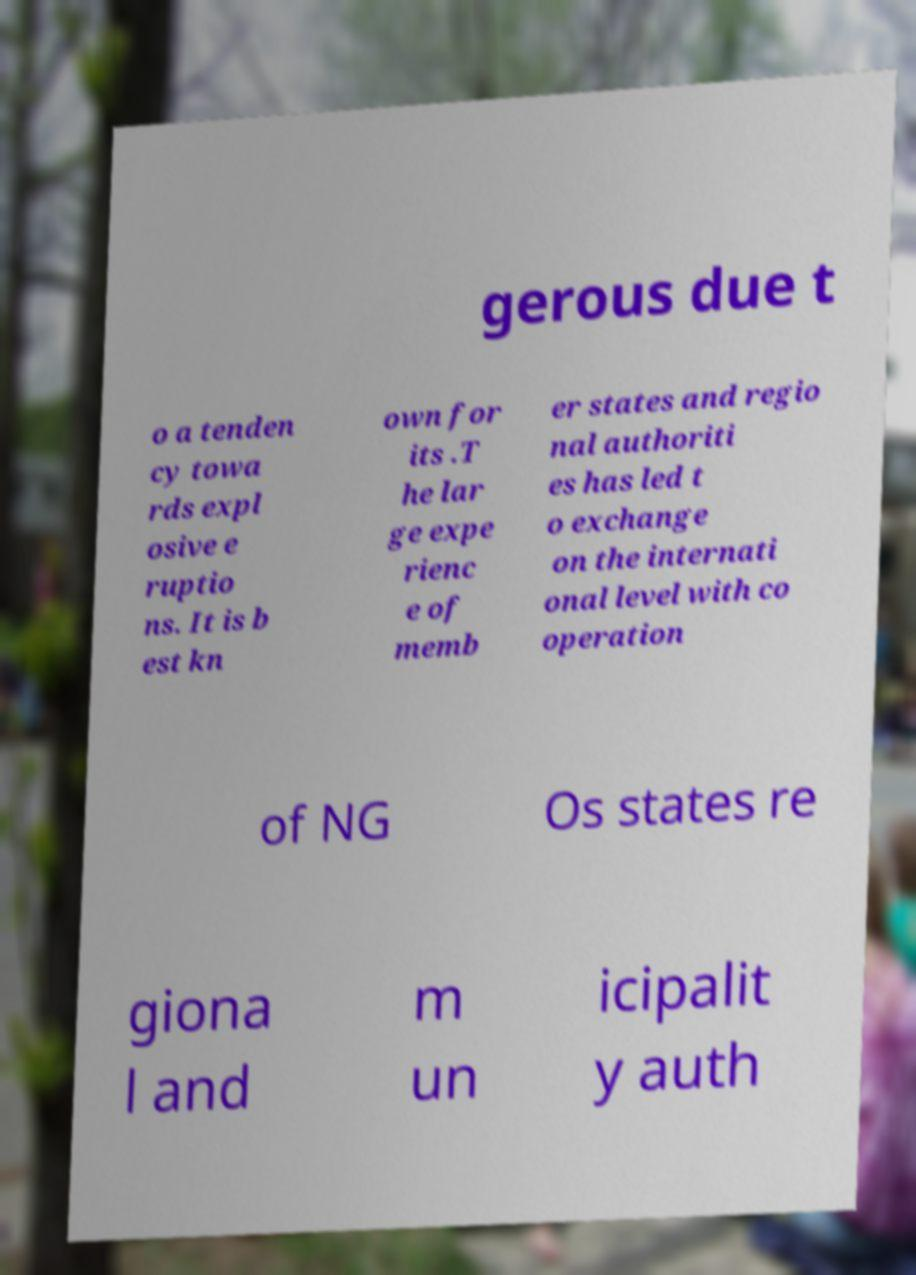There's text embedded in this image that I need extracted. Can you transcribe it verbatim? gerous due t o a tenden cy towa rds expl osive e ruptio ns. It is b est kn own for its .T he lar ge expe rienc e of memb er states and regio nal authoriti es has led t o exchange on the internati onal level with co operation of NG Os states re giona l and m un icipalit y auth 